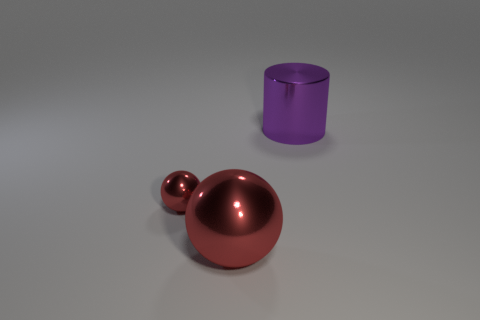Add 2 blue matte blocks. How many objects exist? 5 Subtract all balls. How many objects are left? 1 Add 2 brown blocks. How many brown blocks exist? 2 Subtract 0 cyan balls. How many objects are left? 3 Subtract all cylinders. Subtract all yellow shiny balls. How many objects are left? 2 Add 2 tiny red shiny objects. How many tiny red shiny objects are left? 3 